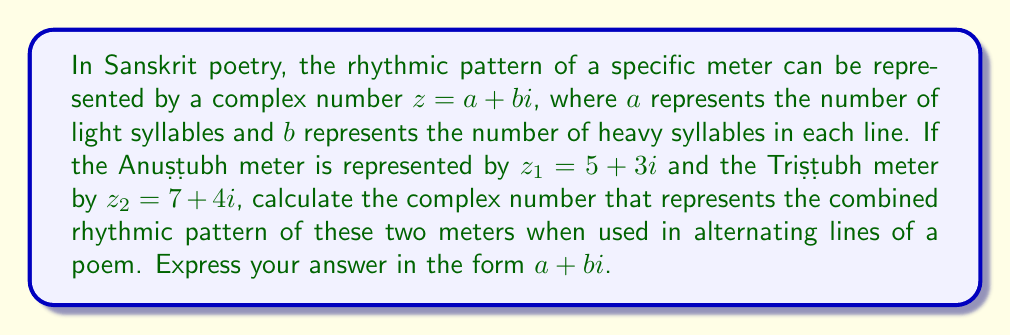Solve this math problem. To find the combined rhythmic pattern of the two meters used in alternating lines, we need to add their complex number representations and then divide by 2 to get the average:

1) First, let's add the two complex numbers:
   $z_1 + z_2 = (5 + 3i) + (7 + 4i)$
   $= (5 + 7) + (3 + 4)i$
   $= 12 + 7i$

2) Now, we need to divide this sum by 2 to get the average:
   $\frac{z_1 + z_2}{2} = \frac{12 + 7i}{2}$

3) We can separate the real and imaginary parts:
   $\frac{12}{2} + \frac{7}{2}i$

4) Simplify:
   $6 + 3.5i$

This complex number represents the average rhythmic pattern when the Anuṣṭubh and Triṣṭubh meters are used in alternating lines. The real part (6) represents the average number of light syllables, and the imaginary part (3.5) represents the average number of heavy syllables per line in this combined meter.
Answer: $6 + 3.5i$ 